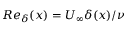Convert formula to latex. <formula><loc_0><loc_0><loc_500><loc_500>R e _ { \delta } ( x ) = U _ { \infty } \delta ( x ) / \nu</formula> 